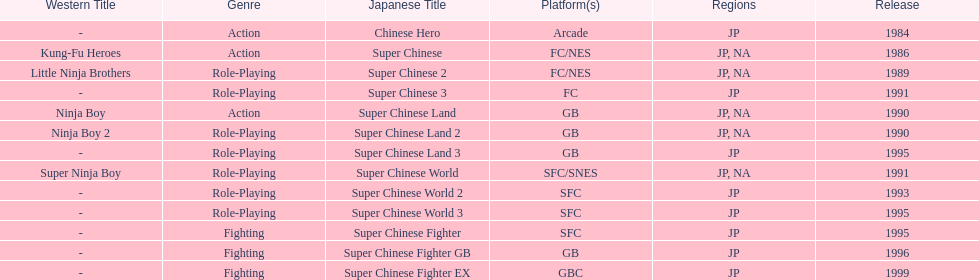When was the last super chinese game released? 1999. 